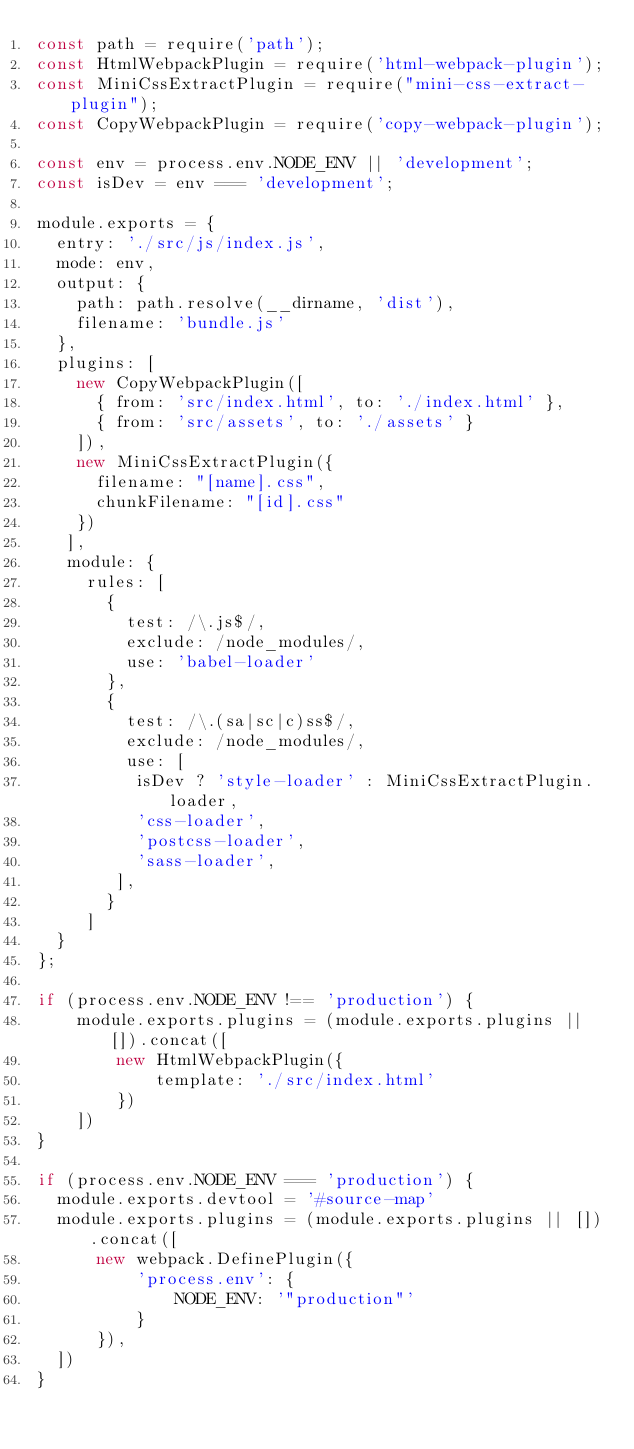<code> <loc_0><loc_0><loc_500><loc_500><_JavaScript_>const path = require('path');
const HtmlWebpackPlugin = require('html-webpack-plugin');
const MiniCssExtractPlugin = require("mini-css-extract-plugin");
const CopyWebpackPlugin = require('copy-webpack-plugin');

const env = process.env.NODE_ENV || 'development';
const isDev = env === 'development';

module.exports = {
  entry: './src/js/index.js',
  mode: env,
  output: {
    path: path.resolve(__dirname, 'dist'),
    filename: 'bundle.js'
  },
  plugins: [
    new CopyWebpackPlugin([
      { from: 'src/index.html', to: './index.html' },
      { from: 'src/assets', to: './assets' }
    ]),
    new MiniCssExtractPlugin({
      filename: "[name].css",
      chunkFilename: "[id].css"
    })
   ],
   module: {
     rules: [
       {
         test: /\.js$/,
         exclude: /node_modules/,
         use: 'babel-loader'
       },
       {
         test: /\.(sa|sc|c)ss$/,
         exclude: /node_modules/,
         use: [
          isDev ? 'style-loader' : MiniCssExtractPlugin.loader,
          'css-loader',
          'postcss-loader',
          'sass-loader',
        ],
       }
     ]
  }
};

if (process.env.NODE_ENV !== 'production') {
    module.exports.plugins = (module.exports.plugins || []).concat([
        new HtmlWebpackPlugin({
            template: './src/index.html'
        })
    ])
}

if (process.env.NODE_ENV === 'production') {
  module.exports.devtool = '#source-map'
  module.exports.plugins = (module.exports.plugins || []).concat([
      new webpack.DefinePlugin({
          'process.env': {
              NODE_ENV: '"production"'
          }
      }),
  ])
}
</code> 